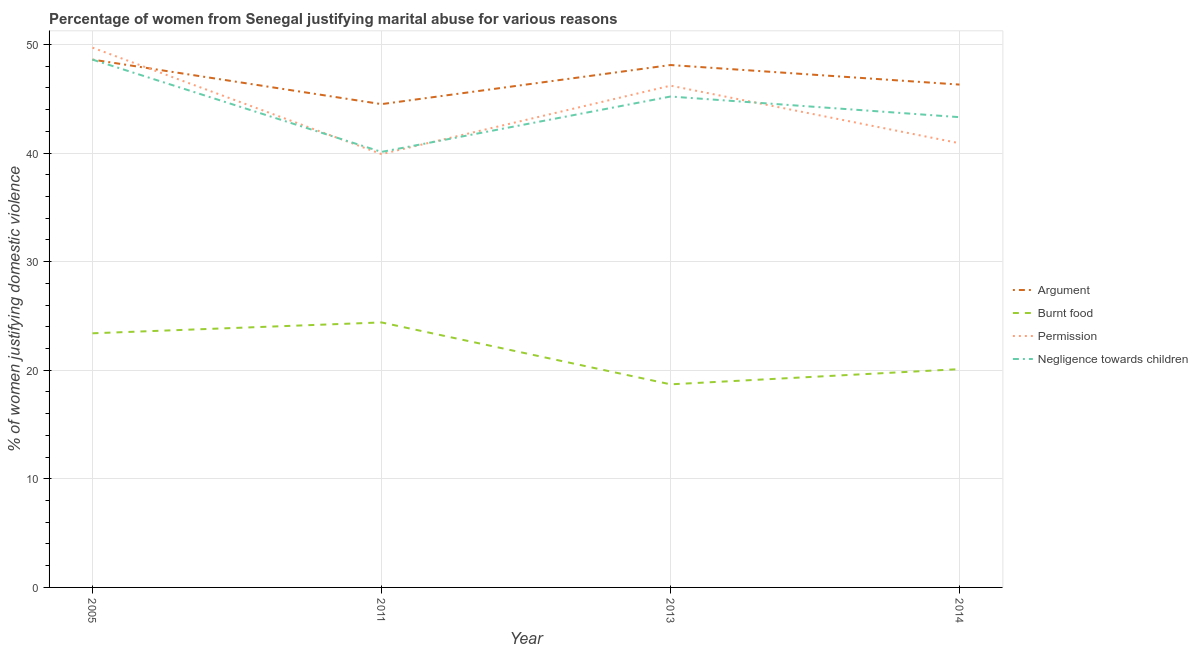Does the line corresponding to percentage of women justifying abuse for going without permission intersect with the line corresponding to percentage of women justifying abuse for burning food?
Provide a short and direct response. No. Is the number of lines equal to the number of legend labels?
Your answer should be very brief. Yes. What is the percentage of women justifying abuse in the case of an argument in 2014?
Provide a succinct answer. 46.3. Across all years, what is the maximum percentage of women justifying abuse for burning food?
Offer a terse response. 24.4. Across all years, what is the minimum percentage of women justifying abuse for showing negligence towards children?
Your answer should be compact. 40.1. In which year was the percentage of women justifying abuse in the case of an argument maximum?
Your answer should be very brief. 2005. What is the total percentage of women justifying abuse for burning food in the graph?
Provide a short and direct response. 86.6. What is the difference between the percentage of women justifying abuse in the case of an argument in 2011 and that in 2013?
Provide a short and direct response. -3.6. What is the difference between the percentage of women justifying abuse in the case of an argument in 2011 and the percentage of women justifying abuse for going without permission in 2014?
Your response must be concise. 3.6. What is the average percentage of women justifying abuse for burning food per year?
Keep it short and to the point. 21.65. In the year 2005, what is the difference between the percentage of women justifying abuse for showing negligence towards children and percentage of women justifying abuse for burning food?
Offer a very short reply. 25.2. In how many years, is the percentage of women justifying abuse for showing negligence towards children greater than 40 %?
Keep it short and to the point. 4. What is the ratio of the percentage of women justifying abuse for going without permission in 2005 to that in 2013?
Provide a succinct answer. 1.08. Is the percentage of women justifying abuse for showing negligence towards children in 2011 less than that in 2014?
Give a very brief answer. Yes. Is the difference between the percentage of women justifying abuse for showing negligence towards children in 2005 and 2013 greater than the difference between the percentage of women justifying abuse for burning food in 2005 and 2013?
Make the answer very short. No. What is the difference between the highest and the second highest percentage of women justifying abuse for going without permission?
Make the answer very short. 3.5. What is the difference between the highest and the lowest percentage of women justifying abuse for burning food?
Provide a short and direct response. 5.7. In how many years, is the percentage of women justifying abuse for burning food greater than the average percentage of women justifying abuse for burning food taken over all years?
Your answer should be very brief. 2. Is the sum of the percentage of women justifying abuse for showing negligence towards children in 2005 and 2013 greater than the maximum percentage of women justifying abuse for going without permission across all years?
Your answer should be very brief. Yes. Is it the case that in every year, the sum of the percentage of women justifying abuse in the case of an argument and percentage of women justifying abuse for burning food is greater than the percentage of women justifying abuse for going without permission?
Your answer should be compact. Yes. Is the percentage of women justifying abuse for going without permission strictly less than the percentage of women justifying abuse for burning food over the years?
Your answer should be very brief. No. Does the graph contain any zero values?
Ensure brevity in your answer.  No. Does the graph contain grids?
Keep it short and to the point. Yes. Where does the legend appear in the graph?
Your answer should be very brief. Center right. How are the legend labels stacked?
Give a very brief answer. Vertical. What is the title of the graph?
Provide a short and direct response. Percentage of women from Senegal justifying marital abuse for various reasons. Does "Rule based governance" appear as one of the legend labels in the graph?
Keep it short and to the point. No. What is the label or title of the Y-axis?
Provide a succinct answer. % of women justifying domestic violence. What is the % of women justifying domestic violence in Argument in 2005?
Your answer should be compact. 48.6. What is the % of women justifying domestic violence of Burnt food in 2005?
Keep it short and to the point. 23.4. What is the % of women justifying domestic violence of Permission in 2005?
Ensure brevity in your answer.  49.7. What is the % of women justifying domestic violence of Negligence towards children in 2005?
Make the answer very short. 48.6. What is the % of women justifying domestic violence of Argument in 2011?
Offer a very short reply. 44.5. What is the % of women justifying domestic violence in Burnt food in 2011?
Make the answer very short. 24.4. What is the % of women justifying domestic violence in Permission in 2011?
Your answer should be compact. 39.9. What is the % of women justifying domestic violence of Negligence towards children in 2011?
Ensure brevity in your answer.  40.1. What is the % of women justifying domestic violence in Argument in 2013?
Provide a short and direct response. 48.1. What is the % of women justifying domestic violence in Burnt food in 2013?
Your answer should be compact. 18.7. What is the % of women justifying domestic violence of Permission in 2013?
Your answer should be compact. 46.2. What is the % of women justifying domestic violence of Negligence towards children in 2013?
Keep it short and to the point. 45.2. What is the % of women justifying domestic violence of Argument in 2014?
Offer a terse response. 46.3. What is the % of women justifying domestic violence of Burnt food in 2014?
Your answer should be very brief. 20.1. What is the % of women justifying domestic violence in Permission in 2014?
Provide a succinct answer. 40.9. What is the % of women justifying domestic violence in Negligence towards children in 2014?
Offer a terse response. 43.3. Across all years, what is the maximum % of women justifying domestic violence in Argument?
Give a very brief answer. 48.6. Across all years, what is the maximum % of women justifying domestic violence of Burnt food?
Provide a short and direct response. 24.4. Across all years, what is the maximum % of women justifying domestic violence in Permission?
Give a very brief answer. 49.7. Across all years, what is the maximum % of women justifying domestic violence in Negligence towards children?
Give a very brief answer. 48.6. Across all years, what is the minimum % of women justifying domestic violence in Argument?
Your answer should be very brief. 44.5. Across all years, what is the minimum % of women justifying domestic violence in Permission?
Your answer should be very brief. 39.9. Across all years, what is the minimum % of women justifying domestic violence of Negligence towards children?
Offer a very short reply. 40.1. What is the total % of women justifying domestic violence of Argument in the graph?
Make the answer very short. 187.5. What is the total % of women justifying domestic violence of Burnt food in the graph?
Your answer should be compact. 86.6. What is the total % of women justifying domestic violence of Permission in the graph?
Make the answer very short. 176.7. What is the total % of women justifying domestic violence in Negligence towards children in the graph?
Ensure brevity in your answer.  177.2. What is the difference between the % of women justifying domestic violence in Burnt food in 2005 and that in 2011?
Your answer should be compact. -1. What is the difference between the % of women justifying domestic violence in Permission in 2005 and that in 2011?
Make the answer very short. 9.8. What is the difference between the % of women justifying domestic violence in Negligence towards children in 2005 and that in 2011?
Offer a very short reply. 8.5. What is the difference between the % of women justifying domestic violence of Argument in 2005 and that in 2013?
Provide a short and direct response. 0.5. What is the difference between the % of women justifying domestic violence in Burnt food in 2005 and that in 2013?
Ensure brevity in your answer.  4.7. What is the difference between the % of women justifying domestic violence in Permission in 2005 and that in 2013?
Ensure brevity in your answer.  3.5. What is the difference between the % of women justifying domestic violence in Argument in 2005 and that in 2014?
Make the answer very short. 2.3. What is the difference between the % of women justifying domestic violence in Permission in 2005 and that in 2014?
Offer a terse response. 8.8. What is the difference between the % of women justifying domestic violence of Negligence towards children in 2005 and that in 2014?
Offer a terse response. 5.3. What is the difference between the % of women justifying domestic violence of Argument in 2011 and that in 2013?
Provide a short and direct response. -3.6. What is the difference between the % of women justifying domestic violence in Argument in 2011 and that in 2014?
Your answer should be very brief. -1.8. What is the difference between the % of women justifying domestic violence of Burnt food in 2011 and that in 2014?
Your response must be concise. 4.3. What is the difference between the % of women justifying domestic violence in Permission in 2011 and that in 2014?
Ensure brevity in your answer.  -1. What is the difference between the % of women justifying domestic violence of Negligence towards children in 2011 and that in 2014?
Provide a short and direct response. -3.2. What is the difference between the % of women justifying domestic violence of Burnt food in 2013 and that in 2014?
Your answer should be very brief. -1.4. What is the difference between the % of women justifying domestic violence in Permission in 2013 and that in 2014?
Your answer should be compact. 5.3. What is the difference between the % of women justifying domestic violence of Argument in 2005 and the % of women justifying domestic violence of Burnt food in 2011?
Provide a short and direct response. 24.2. What is the difference between the % of women justifying domestic violence in Argument in 2005 and the % of women justifying domestic violence in Permission in 2011?
Your response must be concise. 8.7. What is the difference between the % of women justifying domestic violence of Burnt food in 2005 and the % of women justifying domestic violence of Permission in 2011?
Offer a terse response. -16.5. What is the difference between the % of women justifying domestic violence of Burnt food in 2005 and the % of women justifying domestic violence of Negligence towards children in 2011?
Ensure brevity in your answer.  -16.7. What is the difference between the % of women justifying domestic violence of Argument in 2005 and the % of women justifying domestic violence of Burnt food in 2013?
Offer a terse response. 29.9. What is the difference between the % of women justifying domestic violence in Argument in 2005 and the % of women justifying domestic violence in Negligence towards children in 2013?
Offer a very short reply. 3.4. What is the difference between the % of women justifying domestic violence of Burnt food in 2005 and the % of women justifying domestic violence of Permission in 2013?
Make the answer very short. -22.8. What is the difference between the % of women justifying domestic violence in Burnt food in 2005 and the % of women justifying domestic violence in Negligence towards children in 2013?
Offer a very short reply. -21.8. What is the difference between the % of women justifying domestic violence of Permission in 2005 and the % of women justifying domestic violence of Negligence towards children in 2013?
Your answer should be compact. 4.5. What is the difference between the % of women justifying domestic violence in Argument in 2005 and the % of women justifying domestic violence in Burnt food in 2014?
Give a very brief answer. 28.5. What is the difference between the % of women justifying domestic violence of Argument in 2005 and the % of women justifying domestic violence of Negligence towards children in 2014?
Make the answer very short. 5.3. What is the difference between the % of women justifying domestic violence in Burnt food in 2005 and the % of women justifying domestic violence in Permission in 2014?
Make the answer very short. -17.5. What is the difference between the % of women justifying domestic violence of Burnt food in 2005 and the % of women justifying domestic violence of Negligence towards children in 2014?
Ensure brevity in your answer.  -19.9. What is the difference between the % of women justifying domestic violence of Argument in 2011 and the % of women justifying domestic violence of Burnt food in 2013?
Your answer should be compact. 25.8. What is the difference between the % of women justifying domestic violence in Burnt food in 2011 and the % of women justifying domestic violence in Permission in 2013?
Your answer should be compact. -21.8. What is the difference between the % of women justifying domestic violence in Burnt food in 2011 and the % of women justifying domestic violence in Negligence towards children in 2013?
Keep it short and to the point. -20.8. What is the difference between the % of women justifying domestic violence of Argument in 2011 and the % of women justifying domestic violence of Burnt food in 2014?
Provide a short and direct response. 24.4. What is the difference between the % of women justifying domestic violence in Argument in 2011 and the % of women justifying domestic violence in Permission in 2014?
Your answer should be very brief. 3.6. What is the difference between the % of women justifying domestic violence in Burnt food in 2011 and the % of women justifying domestic violence in Permission in 2014?
Offer a very short reply. -16.5. What is the difference between the % of women justifying domestic violence in Burnt food in 2011 and the % of women justifying domestic violence in Negligence towards children in 2014?
Your response must be concise. -18.9. What is the difference between the % of women justifying domestic violence of Permission in 2011 and the % of women justifying domestic violence of Negligence towards children in 2014?
Make the answer very short. -3.4. What is the difference between the % of women justifying domestic violence of Argument in 2013 and the % of women justifying domestic violence of Permission in 2014?
Offer a terse response. 7.2. What is the difference between the % of women justifying domestic violence of Argument in 2013 and the % of women justifying domestic violence of Negligence towards children in 2014?
Make the answer very short. 4.8. What is the difference between the % of women justifying domestic violence in Burnt food in 2013 and the % of women justifying domestic violence in Permission in 2014?
Ensure brevity in your answer.  -22.2. What is the difference between the % of women justifying domestic violence of Burnt food in 2013 and the % of women justifying domestic violence of Negligence towards children in 2014?
Provide a succinct answer. -24.6. What is the average % of women justifying domestic violence of Argument per year?
Your answer should be very brief. 46.88. What is the average % of women justifying domestic violence in Burnt food per year?
Keep it short and to the point. 21.65. What is the average % of women justifying domestic violence of Permission per year?
Provide a succinct answer. 44.17. What is the average % of women justifying domestic violence of Negligence towards children per year?
Your answer should be compact. 44.3. In the year 2005, what is the difference between the % of women justifying domestic violence in Argument and % of women justifying domestic violence in Burnt food?
Your answer should be compact. 25.2. In the year 2005, what is the difference between the % of women justifying domestic violence in Argument and % of women justifying domestic violence in Permission?
Provide a short and direct response. -1.1. In the year 2005, what is the difference between the % of women justifying domestic violence of Burnt food and % of women justifying domestic violence of Permission?
Your answer should be very brief. -26.3. In the year 2005, what is the difference between the % of women justifying domestic violence in Burnt food and % of women justifying domestic violence in Negligence towards children?
Ensure brevity in your answer.  -25.2. In the year 2005, what is the difference between the % of women justifying domestic violence in Permission and % of women justifying domestic violence in Negligence towards children?
Keep it short and to the point. 1.1. In the year 2011, what is the difference between the % of women justifying domestic violence in Argument and % of women justifying domestic violence in Burnt food?
Offer a very short reply. 20.1. In the year 2011, what is the difference between the % of women justifying domestic violence in Argument and % of women justifying domestic violence in Permission?
Your answer should be very brief. 4.6. In the year 2011, what is the difference between the % of women justifying domestic violence in Burnt food and % of women justifying domestic violence in Permission?
Offer a terse response. -15.5. In the year 2011, what is the difference between the % of women justifying domestic violence of Burnt food and % of women justifying domestic violence of Negligence towards children?
Offer a terse response. -15.7. In the year 2011, what is the difference between the % of women justifying domestic violence of Permission and % of women justifying domestic violence of Negligence towards children?
Offer a very short reply. -0.2. In the year 2013, what is the difference between the % of women justifying domestic violence of Argument and % of women justifying domestic violence of Burnt food?
Offer a terse response. 29.4. In the year 2013, what is the difference between the % of women justifying domestic violence in Argument and % of women justifying domestic violence in Permission?
Your answer should be compact. 1.9. In the year 2013, what is the difference between the % of women justifying domestic violence of Argument and % of women justifying domestic violence of Negligence towards children?
Your answer should be compact. 2.9. In the year 2013, what is the difference between the % of women justifying domestic violence of Burnt food and % of women justifying domestic violence of Permission?
Offer a very short reply. -27.5. In the year 2013, what is the difference between the % of women justifying domestic violence of Burnt food and % of women justifying domestic violence of Negligence towards children?
Offer a very short reply. -26.5. In the year 2014, what is the difference between the % of women justifying domestic violence of Argument and % of women justifying domestic violence of Burnt food?
Provide a short and direct response. 26.2. In the year 2014, what is the difference between the % of women justifying domestic violence in Argument and % of women justifying domestic violence in Permission?
Provide a short and direct response. 5.4. In the year 2014, what is the difference between the % of women justifying domestic violence in Burnt food and % of women justifying domestic violence in Permission?
Your response must be concise. -20.8. In the year 2014, what is the difference between the % of women justifying domestic violence of Burnt food and % of women justifying domestic violence of Negligence towards children?
Ensure brevity in your answer.  -23.2. In the year 2014, what is the difference between the % of women justifying domestic violence in Permission and % of women justifying domestic violence in Negligence towards children?
Your response must be concise. -2.4. What is the ratio of the % of women justifying domestic violence in Argument in 2005 to that in 2011?
Ensure brevity in your answer.  1.09. What is the ratio of the % of women justifying domestic violence of Permission in 2005 to that in 2011?
Offer a very short reply. 1.25. What is the ratio of the % of women justifying domestic violence in Negligence towards children in 2005 to that in 2011?
Provide a short and direct response. 1.21. What is the ratio of the % of women justifying domestic violence of Argument in 2005 to that in 2013?
Ensure brevity in your answer.  1.01. What is the ratio of the % of women justifying domestic violence of Burnt food in 2005 to that in 2013?
Make the answer very short. 1.25. What is the ratio of the % of women justifying domestic violence of Permission in 2005 to that in 2013?
Offer a very short reply. 1.08. What is the ratio of the % of women justifying domestic violence of Negligence towards children in 2005 to that in 2013?
Offer a very short reply. 1.08. What is the ratio of the % of women justifying domestic violence of Argument in 2005 to that in 2014?
Offer a terse response. 1.05. What is the ratio of the % of women justifying domestic violence in Burnt food in 2005 to that in 2014?
Your answer should be compact. 1.16. What is the ratio of the % of women justifying domestic violence in Permission in 2005 to that in 2014?
Keep it short and to the point. 1.22. What is the ratio of the % of women justifying domestic violence of Negligence towards children in 2005 to that in 2014?
Provide a succinct answer. 1.12. What is the ratio of the % of women justifying domestic violence in Argument in 2011 to that in 2013?
Provide a succinct answer. 0.93. What is the ratio of the % of women justifying domestic violence of Burnt food in 2011 to that in 2013?
Keep it short and to the point. 1.3. What is the ratio of the % of women justifying domestic violence in Permission in 2011 to that in 2013?
Your answer should be compact. 0.86. What is the ratio of the % of women justifying domestic violence in Negligence towards children in 2011 to that in 2013?
Provide a short and direct response. 0.89. What is the ratio of the % of women justifying domestic violence of Argument in 2011 to that in 2014?
Make the answer very short. 0.96. What is the ratio of the % of women justifying domestic violence in Burnt food in 2011 to that in 2014?
Keep it short and to the point. 1.21. What is the ratio of the % of women justifying domestic violence of Permission in 2011 to that in 2014?
Your answer should be compact. 0.98. What is the ratio of the % of women justifying domestic violence of Negligence towards children in 2011 to that in 2014?
Offer a very short reply. 0.93. What is the ratio of the % of women justifying domestic violence in Argument in 2013 to that in 2014?
Keep it short and to the point. 1.04. What is the ratio of the % of women justifying domestic violence in Burnt food in 2013 to that in 2014?
Your answer should be compact. 0.93. What is the ratio of the % of women justifying domestic violence in Permission in 2013 to that in 2014?
Your answer should be very brief. 1.13. What is the ratio of the % of women justifying domestic violence of Negligence towards children in 2013 to that in 2014?
Give a very brief answer. 1.04. What is the difference between the highest and the second highest % of women justifying domestic violence of Argument?
Make the answer very short. 0.5. What is the difference between the highest and the second highest % of women justifying domestic violence in Burnt food?
Offer a terse response. 1. What is the difference between the highest and the second highest % of women justifying domestic violence of Permission?
Make the answer very short. 3.5. What is the difference between the highest and the second highest % of women justifying domestic violence of Negligence towards children?
Give a very brief answer. 3.4. What is the difference between the highest and the lowest % of women justifying domestic violence of Burnt food?
Ensure brevity in your answer.  5.7. What is the difference between the highest and the lowest % of women justifying domestic violence of Permission?
Offer a very short reply. 9.8. 